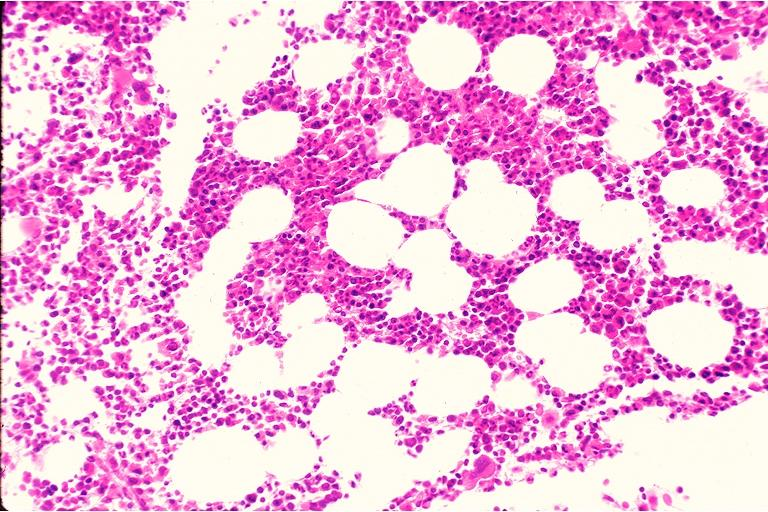does hypertension show hematopoietic bone marrow defect?
Answer the question using a single word or phrase. No 